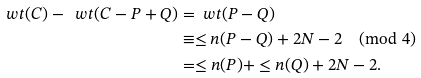<formula> <loc_0><loc_0><loc_500><loc_500>\ w t ( C ) - \ w t ( C - P + Q ) & = \ w t ( P - Q ) \\ & \equiv \leq n ( P - Q ) + 2 N - 2 \pmod { 4 } \\ & = \leq n ( P ) + \leq n ( Q ) + 2 N - 2 .</formula> 